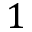<formula> <loc_0><loc_0><loc_500><loc_500>1</formula> 